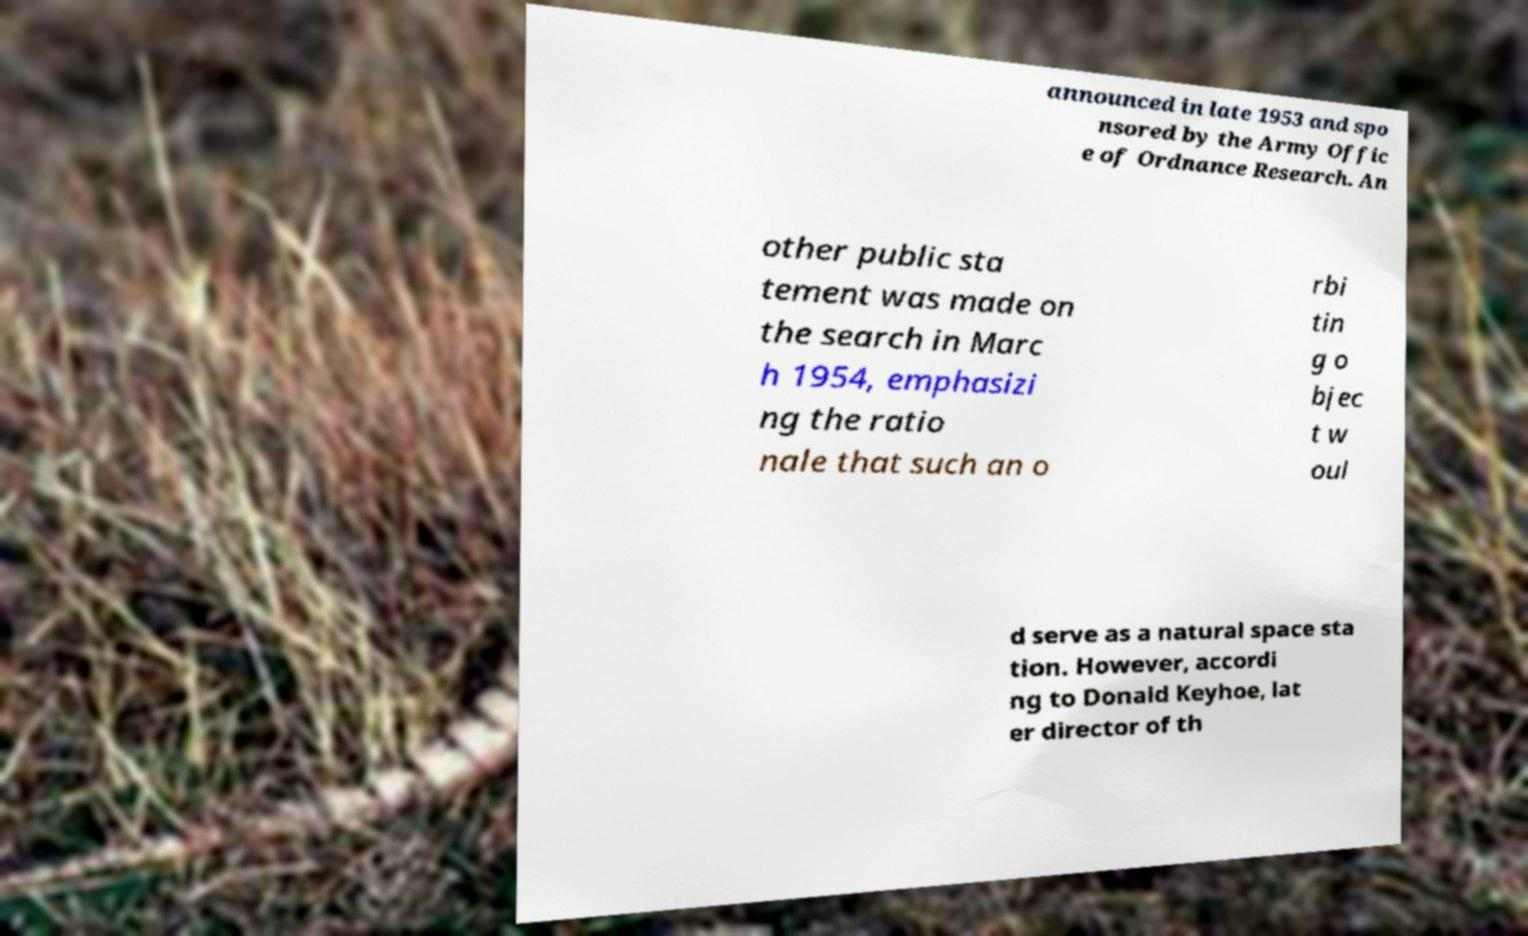For documentation purposes, I need the text within this image transcribed. Could you provide that? announced in late 1953 and spo nsored by the Army Offic e of Ordnance Research. An other public sta tement was made on the search in Marc h 1954, emphasizi ng the ratio nale that such an o rbi tin g o bjec t w oul d serve as a natural space sta tion. However, accordi ng to Donald Keyhoe, lat er director of th 